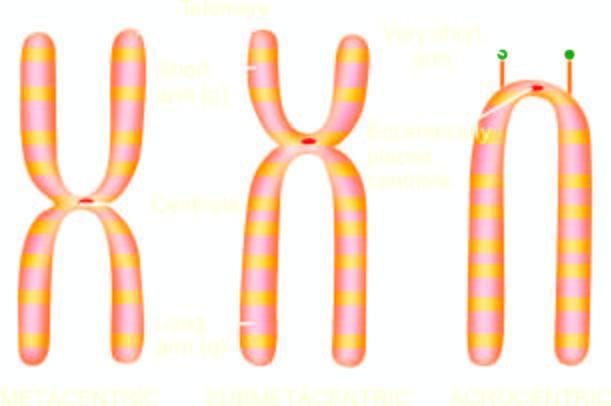s classification of chromosomes base on size and location of centromere?
Answer the question using a single word or phrase. Yes 